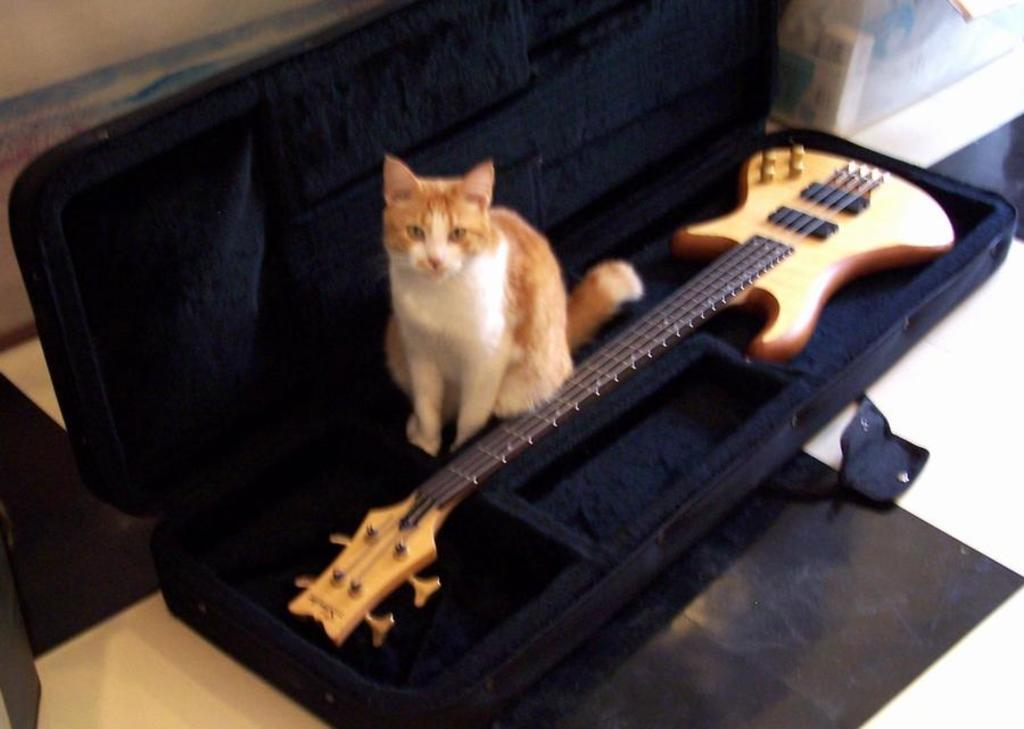What object is present in the image? There is a box in the image. What is inside the box? There is a cat and a guitar inside the box. What can be seen in the background of the image? There is a wall in the background of the image. What type of agreement is being discussed by the family around the desk in the image? There is no family or desk present in the image; it features a box with a cat and a guitar inside, and a wall in the background. 